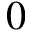<formula> <loc_0><loc_0><loc_500><loc_500>0</formula> 